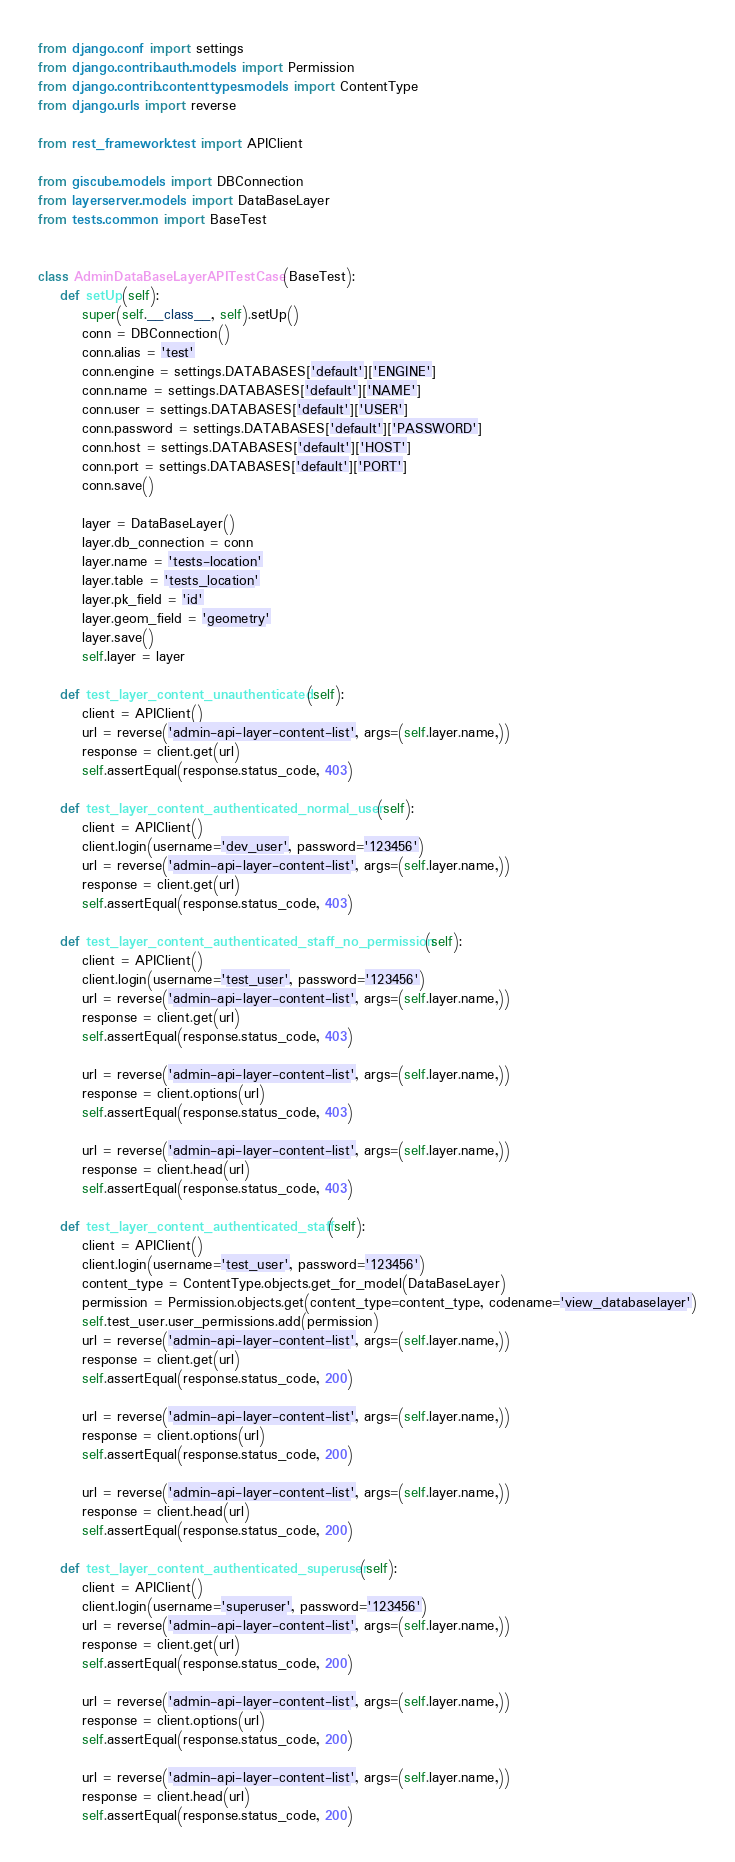<code> <loc_0><loc_0><loc_500><loc_500><_Python_>from django.conf import settings
from django.contrib.auth.models import Permission
from django.contrib.contenttypes.models import ContentType
from django.urls import reverse

from rest_framework.test import APIClient

from giscube.models import DBConnection
from layerserver.models import DataBaseLayer
from tests.common import BaseTest


class AdminDataBaseLayerAPITestCase(BaseTest):
    def setUp(self):
        super(self.__class__, self).setUp()
        conn = DBConnection()
        conn.alias = 'test'
        conn.engine = settings.DATABASES['default']['ENGINE']
        conn.name = settings.DATABASES['default']['NAME']
        conn.user = settings.DATABASES['default']['USER']
        conn.password = settings.DATABASES['default']['PASSWORD']
        conn.host = settings.DATABASES['default']['HOST']
        conn.port = settings.DATABASES['default']['PORT']
        conn.save()

        layer = DataBaseLayer()
        layer.db_connection = conn
        layer.name = 'tests-location'
        layer.table = 'tests_location'
        layer.pk_field = 'id'
        layer.geom_field = 'geometry'
        layer.save()
        self.layer = layer

    def test_layer_content_unauthenticated(self):
        client = APIClient()
        url = reverse('admin-api-layer-content-list', args=(self.layer.name,))
        response = client.get(url)
        self.assertEqual(response.status_code, 403)

    def test_layer_content_authenticated_normal_user(self):
        client = APIClient()
        client.login(username='dev_user', password='123456')
        url = reverse('admin-api-layer-content-list', args=(self.layer.name,))
        response = client.get(url)
        self.assertEqual(response.status_code, 403)

    def test_layer_content_authenticated_staff_no_permission(self):
        client = APIClient()
        client.login(username='test_user', password='123456')
        url = reverse('admin-api-layer-content-list', args=(self.layer.name,))
        response = client.get(url)
        self.assertEqual(response.status_code, 403)

        url = reverse('admin-api-layer-content-list', args=(self.layer.name,))
        response = client.options(url)
        self.assertEqual(response.status_code, 403)

        url = reverse('admin-api-layer-content-list', args=(self.layer.name,))
        response = client.head(url)
        self.assertEqual(response.status_code, 403)

    def test_layer_content_authenticated_staff(self):
        client = APIClient()
        client.login(username='test_user', password='123456')
        content_type = ContentType.objects.get_for_model(DataBaseLayer)
        permission = Permission.objects.get(content_type=content_type, codename='view_databaselayer')
        self.test_user.user_permissions.add(permission)
        url = reverse('admin-api-layer-content-list', args=(self.layer.name,))
        response = client.get(url)
        self.assertEqual(response.status_code, 200)

        url = reverse('admin-api-layer-content-list', args=(self.layer.name,))
        response = client.options(url)
        self.assertEqual(response.status_code, 200)

        url = reverse('admin-api-layer-content-list', args=(self.layer.name,))
        response = client.head(url)
        self.assertEqual(response.status_code, 200)

    def test_layer_content_authenticated_superuser(self):
        client = APIClient()
        client.login(username='superuser', password='123456')
        url = reverse('admin-api-layer-content-list', args=(self.layer.name,))
        response = client.get(url)
        self.assertEqual(response.status_code, 200)

        url = reverse('admin-api-layer-content-list', args=(self.layer.name,))
        response = client.options(url)
        self.assertEqual(response.status_code, 200)

        url = reverse('admin-api-layer-content-list', args=(self.layer.name,))
        response = client.head(url)
        self.assertEqual(response.status_code, 200)
</code> 